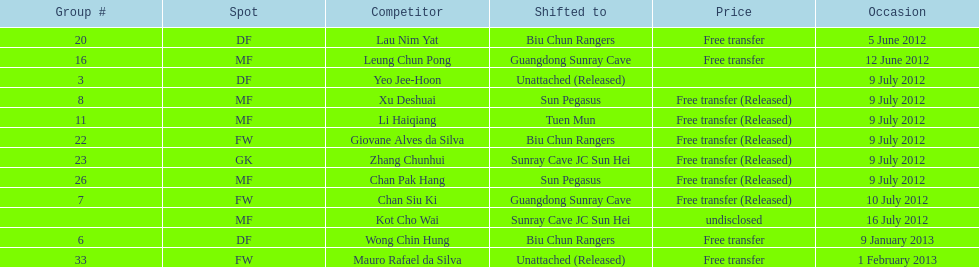How many total players were transferred to sun pegasus? 2. 